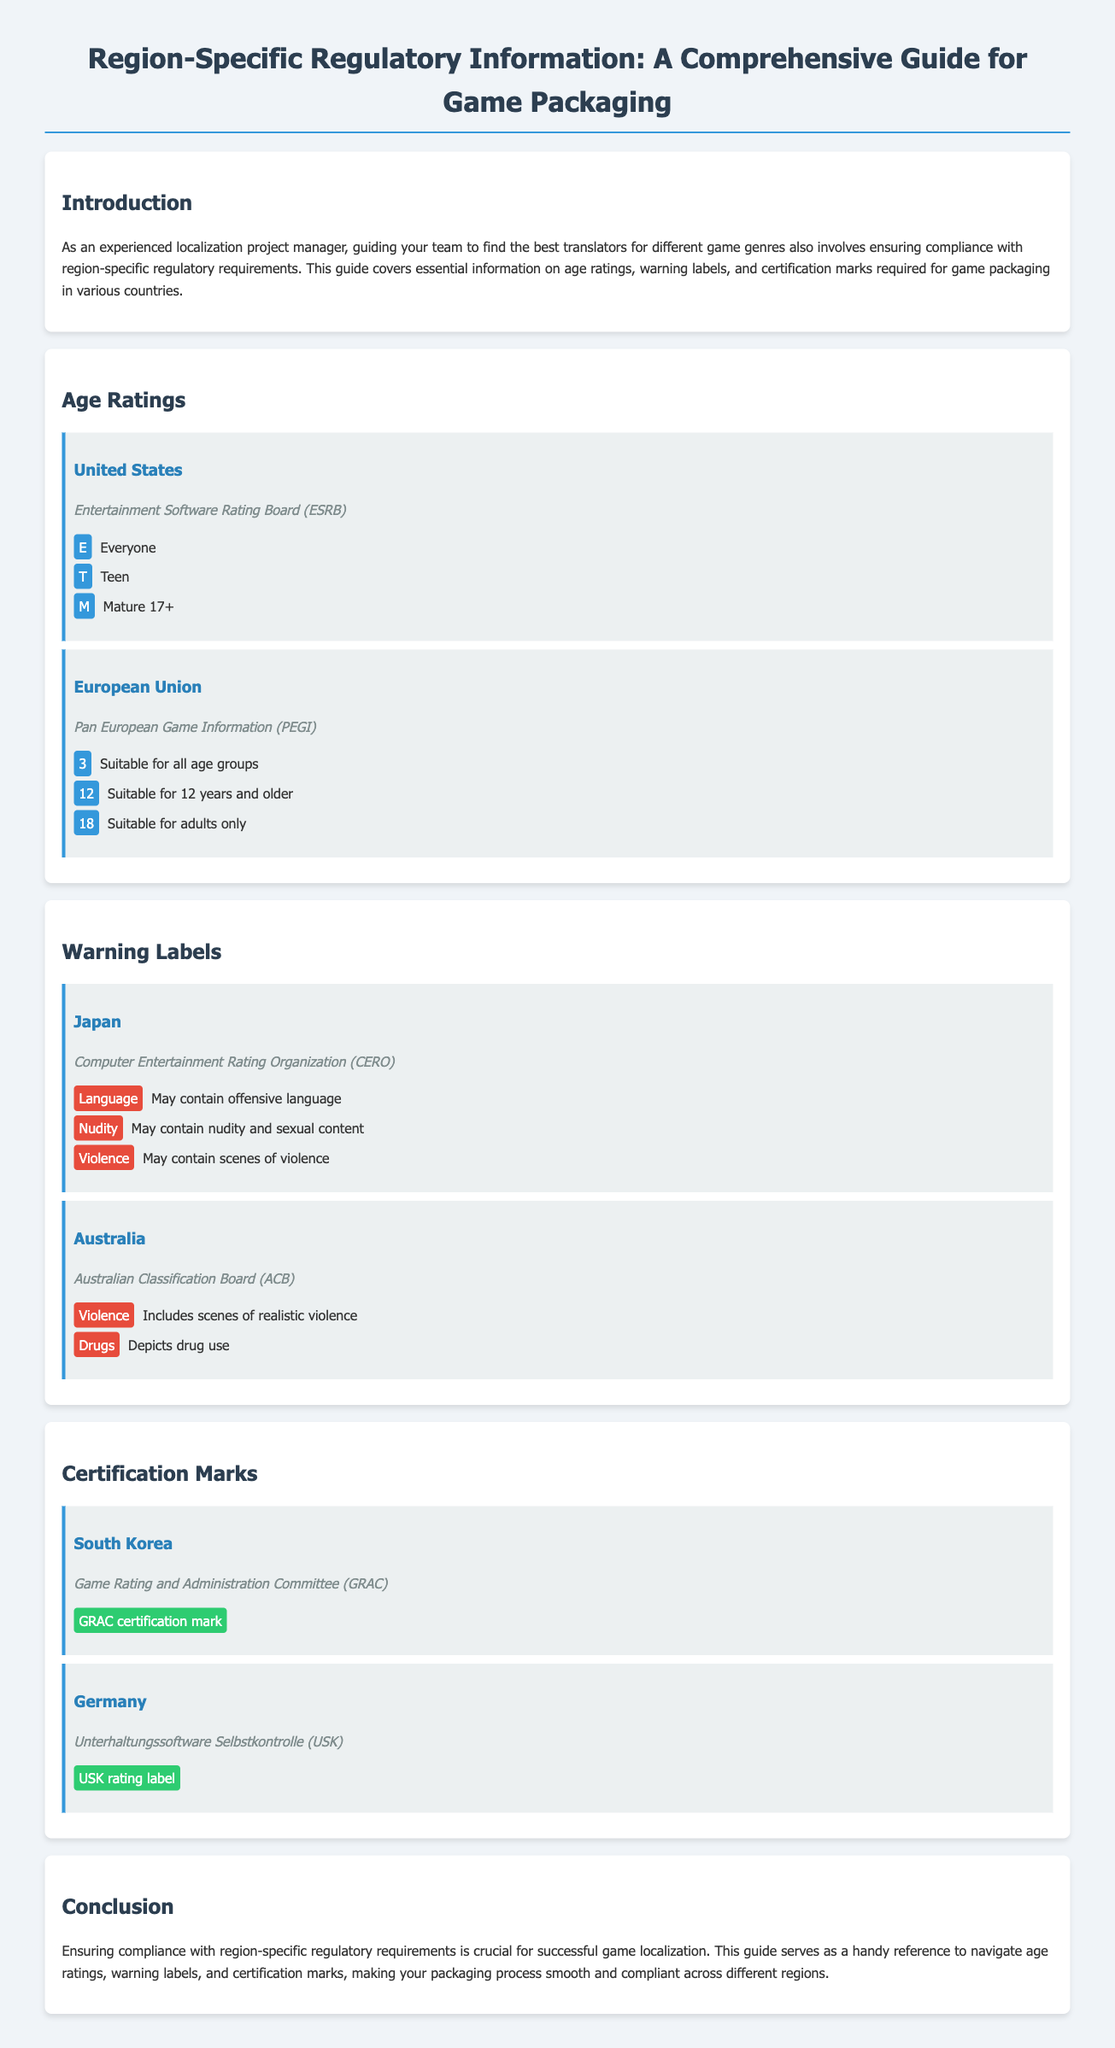what organization is responsible for age ratings in the United States? The document states that the organization is the Entertainment Software Rating Board (ESRB) which is responsible for age ratings in the United States.
Answer: Entertainment Software Rating Board (ESRB) what age rating is suitable for all age groups in the European Union? The document indicates that the age rating suitable for all age groups in the European Union is 3, as governed by the Pan European Game Information (PEGI).
Answer: 3 what warning label is associated with nudity in Japan? The document specifies that in Japan, the warning label associated with nudity is labeled as "May contain nudity and sexual content" under the Computer Entertainment Rating Organization (CERO).
Answer: May contain nudity and sexual content which certification mark is required for game packaging in South Korea? According to the document, the certification mark required for game packaging in South Korea is the GRAC certification mark as per the Game Rating and Administration Committee (GRAC).
Answer: GRAC certification mark how many age ratings does the European Union list in the document? The document lists three age ratings for the European Union: 3, 12, and 18, which means there are a total of three age ratings provided.
Answer: 3 which organization provides warning labels for realistic violence in Australia? The Australian Classification Board (ACB) provides warning labels for realistic violence as mentioned in the document.
Answer: Australian Classification Board (ACB) what does the "M" rating signify in the United States? The document clarifies that the "M" rating signifies Mature 17+, indicating content suitable for players aged 17 years and older.
Answer: Mature 17+ what is the purpose of the document? The purpose of the document is to provide a comprehensive guide on region-specific regulatory requirements for game packaging, ensuring compliance necessary for game localization.
Answer: Comprehensive guide what does the "USK" rating label represent in Germany? In Germany, the "USK" rating label represents the Unterhaltungssoftware Selbstkontrolle, which is the organization responsible for age ratings.
Answer: Unterhaltungssoftware Selbstkontrolle (USK) 